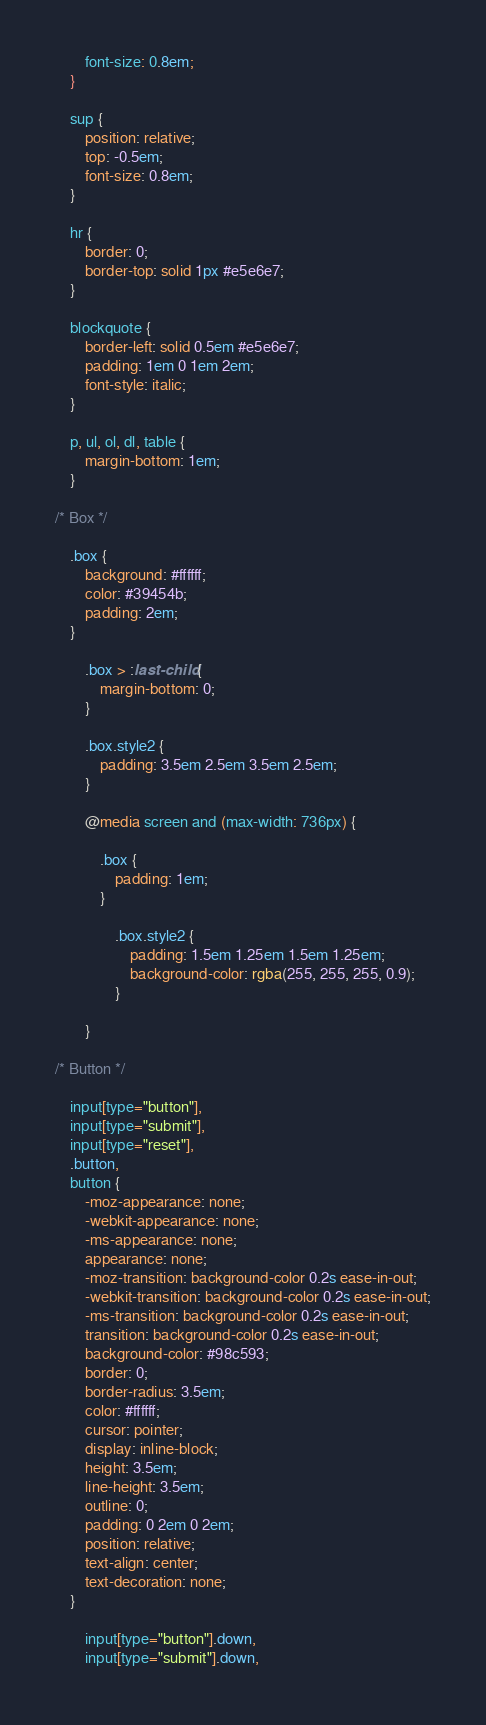<code> <loc_0><loc_0><loc_500><loc_500><_CSS_>		font-size: 0.8em;
	}

	sup {
		position: relative;
		top: -0.5em;
		font-size: 0.8em;
	}

	hr {
		border: 0;
		border-top: solid 1px #e5e6e7;
	}

	blockquote {
		border-left: solid 0.5em #e5e6e7;
		padding: 1em 0 1em 2em;
		font-style: italic;
	}

	p, ul, ol, dl, table {
		margin-bottom: 1em;
	}

/* Box */

	.box {
		background: #ffffff;
		color: #39454b;
		padding: 2em;
	}

		.box > :last-child {
			margin-bottom: 0;
		}

		.box.style2 {
			padding: 3.5em 2.5em 3.5em 2.5em;
		}

		@media screen and (max-width: 736px) {

			.box {
				padding: 1em;
			}

				.box.style2 {
					padding: 1.5em 1.25em 1.5em 1.25em;
					background-color: rgba(255, 255, 255, 0.9);
				}

		}

/* Button */

	input[type="button"],
	input[type="submit"],
	input[type="reset"],
	.button,
	button {
		-moz-appearance: none;
		-webkit-appearance: none;
		-ms-appearance: none;
		appearance: none;
		-moz-transition: background-color 0.2s ease-in-out;
		-webkit-transition: background-color 0.2s ease-in-out;
		-ms-transition: background-color 0.2s ease-in-out;
		transition: background-color 0.2s ease-in-out;
		background-color: #98c593;
		border: 0;
		border-radius: 3.5em;
		color: #ffffff;
		cursor: pointer;
		display: inline-block;
		height: 3.5em;
		line-height: 3.5em;
		outline: 0;
		padding: 0 2em 0 2em;
		position: relative;
		text-align: center;
		text-decoration: none;
	}

		input[type="button"].down,
		input[type="submit"].down,</code> 